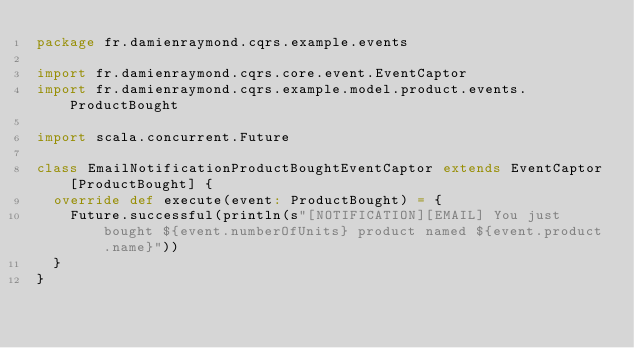<code> <loc_0><loc_0><loc_500><loc_500><_Scala_>package fr.damienraymond.cqrs.example.events

import fr.damienraymond.cqrs.core.event.EventCaptor
import fr.damienraymond.cqrs.example.model.product.events.ProductBought

import scala.concurrent.Future

class EmailNotificationProductBoughtEventCaptor extends EventCaptor[ProductBought] {
  override def execute(event: ProductBought) = {
    Future.successful(println(s"[NOTIFICATION][EMAIL] You just bought ${event.numberOfUnits} product named ${event.product.name}"))
  }
}
</code> 